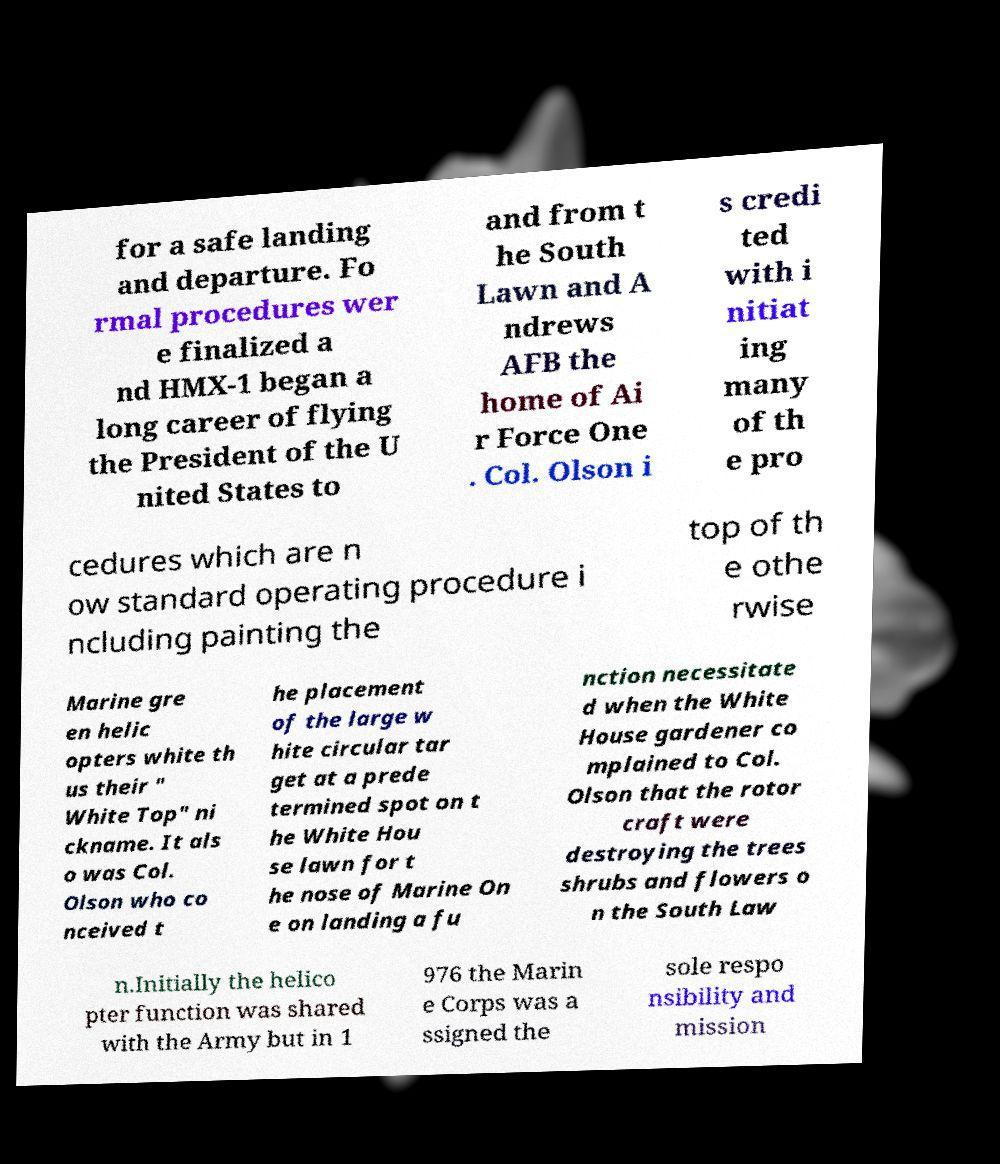Please read and relay the text visible in this image. What does it say? for a safe landing and departure. Fo rmal procedures wer e finalized a nd HMX-1 began a long career of flying the President of the U nited States to and from t he South Lawn and A ndrews AFB the home of Ai r Force One . Col. Olson i s credi ted with i nitiat ing many of th e pro cedures which are n ow standard operating procedure i ncluding painting the top of th e othe rwise Marine gre en helic opters white th us their " White Top" ni ckname. It als o was Col. Olson who co nceived t he placement of the large w hite circular tar get at a prede termined spot on t he White Hou se lawn for t he nose of Marine On e on landing a fu nction necessitate d when the White House gardener co mplained to Col. Olson that the rotor craft were destroying the trees shrubs and flowers o n the South Law n.Initially the helico pter function was shared with the Army but in 1 976 the Marin e Corps was a ssigned the sole respo nsibility and mission 